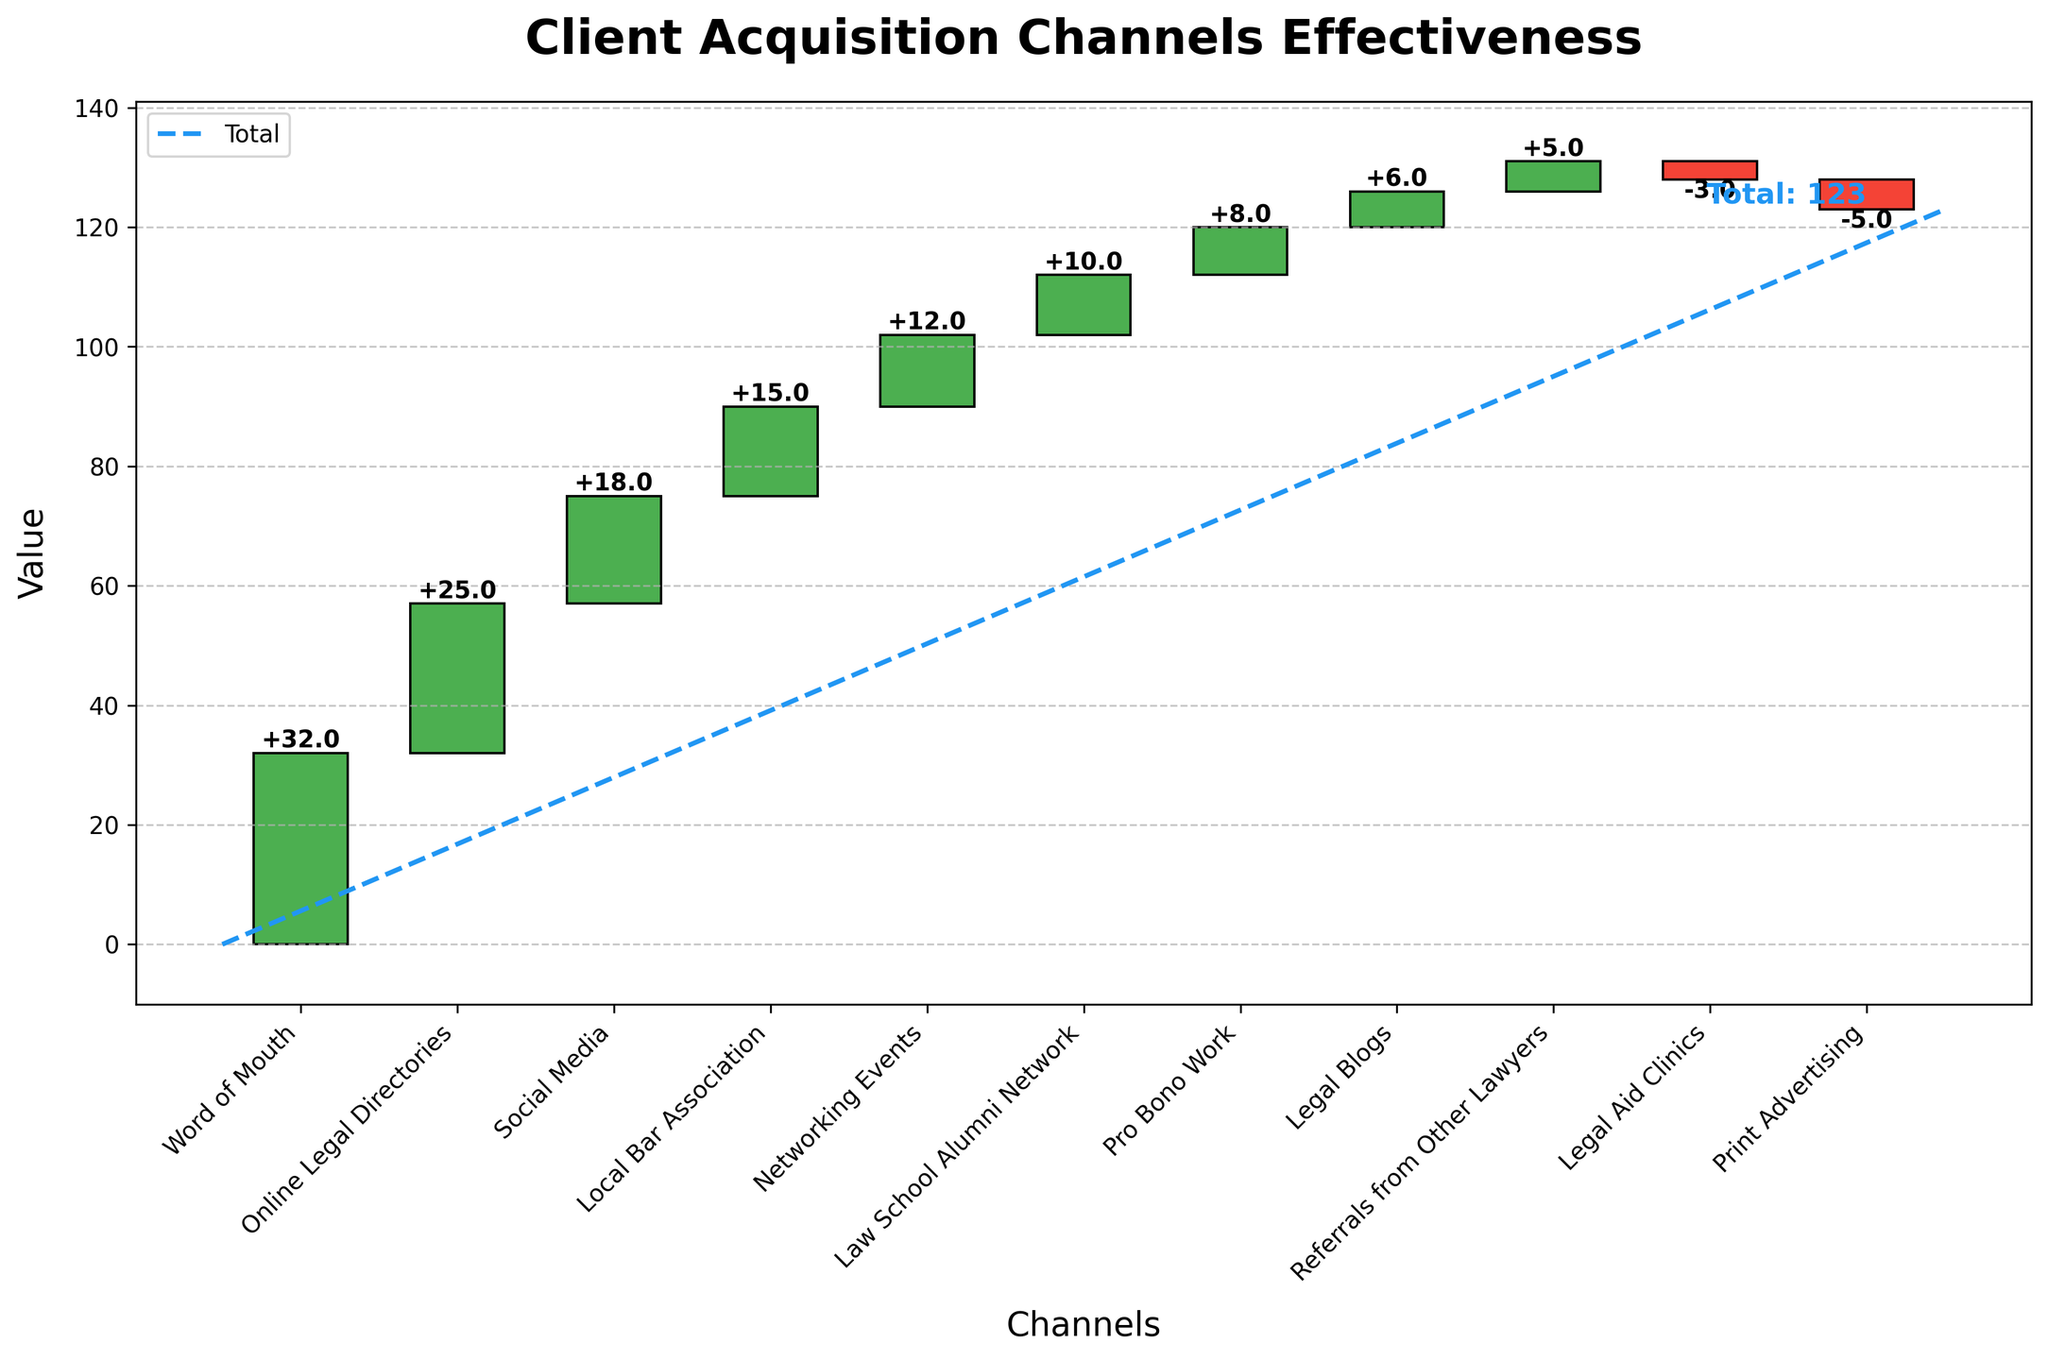What is the title of the figure? The title of the figure is usually found at the top of the plot. In this case, it is displayed prominently to give the viewer an idea of what the chart is about at a glance.
Answer: Client Acquisition Channels Effectiveness Which channel has the highest positive value? The channel with the highest positive value is visualized as the tallest green bar. By comparing the heights of the green bars, we can see that "Word of Mouth" is the tallest.
Answer: Word of Mouth What is the total value represented in the chart? The total value is indicated by a dashed blue line and is also labeled as "Total: 123" at the end of the chart.
Answer: 123 How many channels have negative values? Negative values are represented by red bars. By counting the red bars, we find that there are two channels with negative values.
Answer: 2 What is the cumulative value after "Social Media"? The cumulative value is the sum of all previous positive and negative values up to and including "Social Media." Thus, it is 32 (Word of Mouth) + 25 (Online Legal Directories) + 18 (Social Media).
Answer: 75 How does the effectiveness of "Pro Bono Work" compare to "Legal Blogs"? To compare the effectiveness, we refer to the heights of the bars for these channels. "Pro Bono Work" has a value of 8, while "Legal Blogs" has a value of 6. Therefore, "Pro Bono Work" is more effective by 2 units.
Answer: Pro Bono Work is more effective What is the cumulative sum of values up to and including the "Referrals from Other Lawyers"? To find the cumulative sum up to "Referrals from Other Lawyers," we sum all values before and including this channel: 32 (Word of Mouth) + 25 (Online Legal Directories) + 18 (Social Media) + 15 (Local Bar Association) + 12 (Networking Events) + 10 (Law School Alumni Network) + 8 (Pro Bono Work) + 6 (Legal Blogs) + 5 (Referrals from Other Lawyers).
Answer: 131 What is the color used to denote negative channel values? The color used to denote negative channel values is red, which is consistently used for negative bars in the chart.
Answer: Red How many channels contribute positively to the total value? Positive contributions are indicated by green bars. By counting the green bars, we can determine that there are nine channels that contribute positively.
Answer: 9 